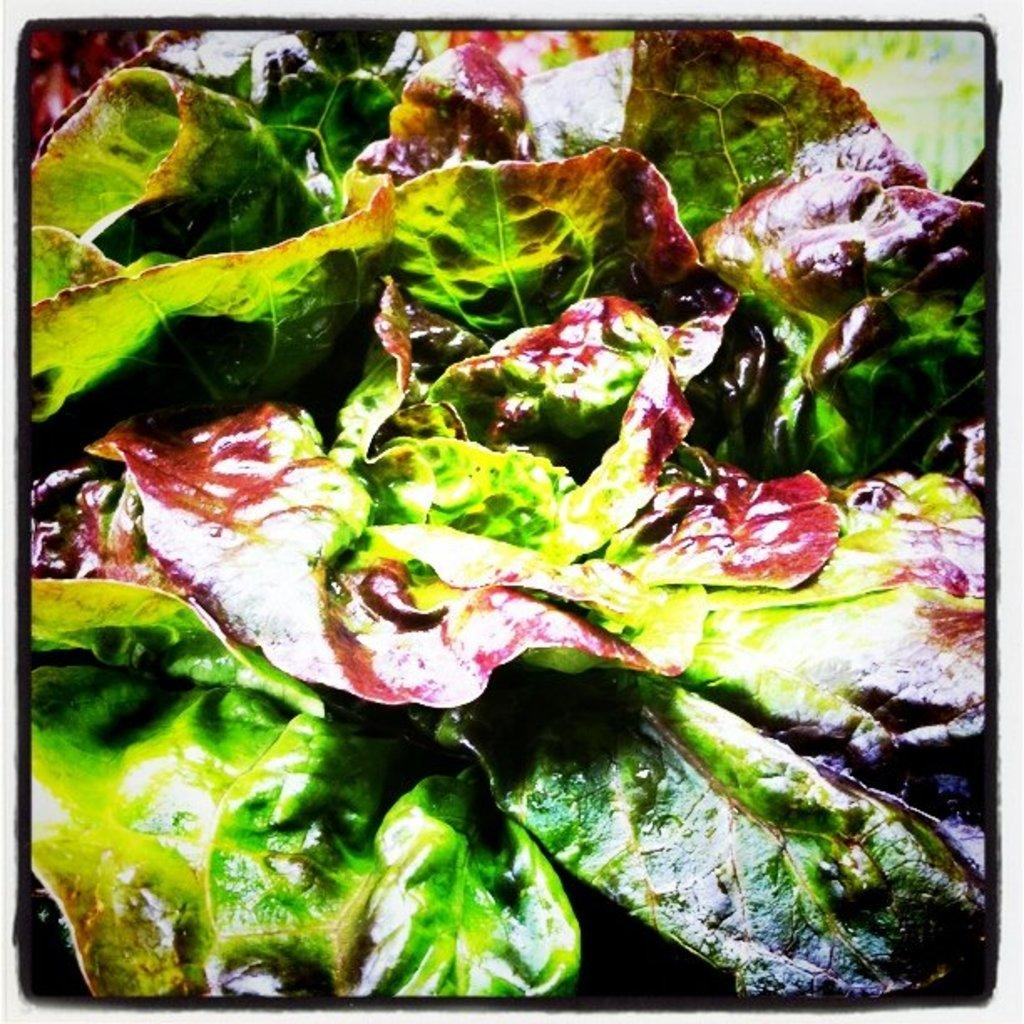What type of vegetation can be seen in the image? There are leaves visible in the image. Can you describe the color or texture of the leaves? The provided facts do not include information about the color or texture of the leaves. Are there any other objects or elements present in the image besides the leaves? The provided facts do not mention any other objects or elements in the image. What hobbies do the leaves enjoy in the image? Leaves do not have hobbies, as they are inanimate objects. 